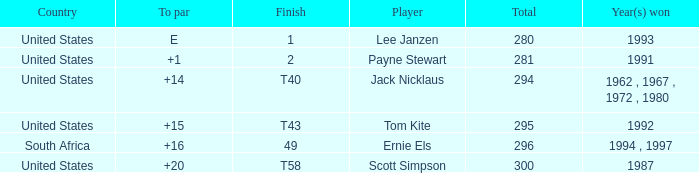Give me the full table as a dictionary. {'header': ['Country', 'To par', 'Finish', 'Player', 'Total', 'Year(s) won'], 'rows': [['United States', 'E', '1', 'Lee Janzen', '280', '1993'], ['United States', '+1', '2', 'Payne Stewart', '281', '1991'], ['United States', '+14', 'T40', 'Jack Nicklaus', '294', '1962 , 1967 , 1972 , 1980'], ['United States', '+15', 'T43', 'Tom Kite', '295', '1992'], ['South Africa', '+16', '49', 'Ernie Els', '296', '1994 , 1997'], ['United States', '+20', 'T58', 'Scott Simpson', '300', '1987']]} What is the Total of the Player with a Finish of 1? 1.0. 